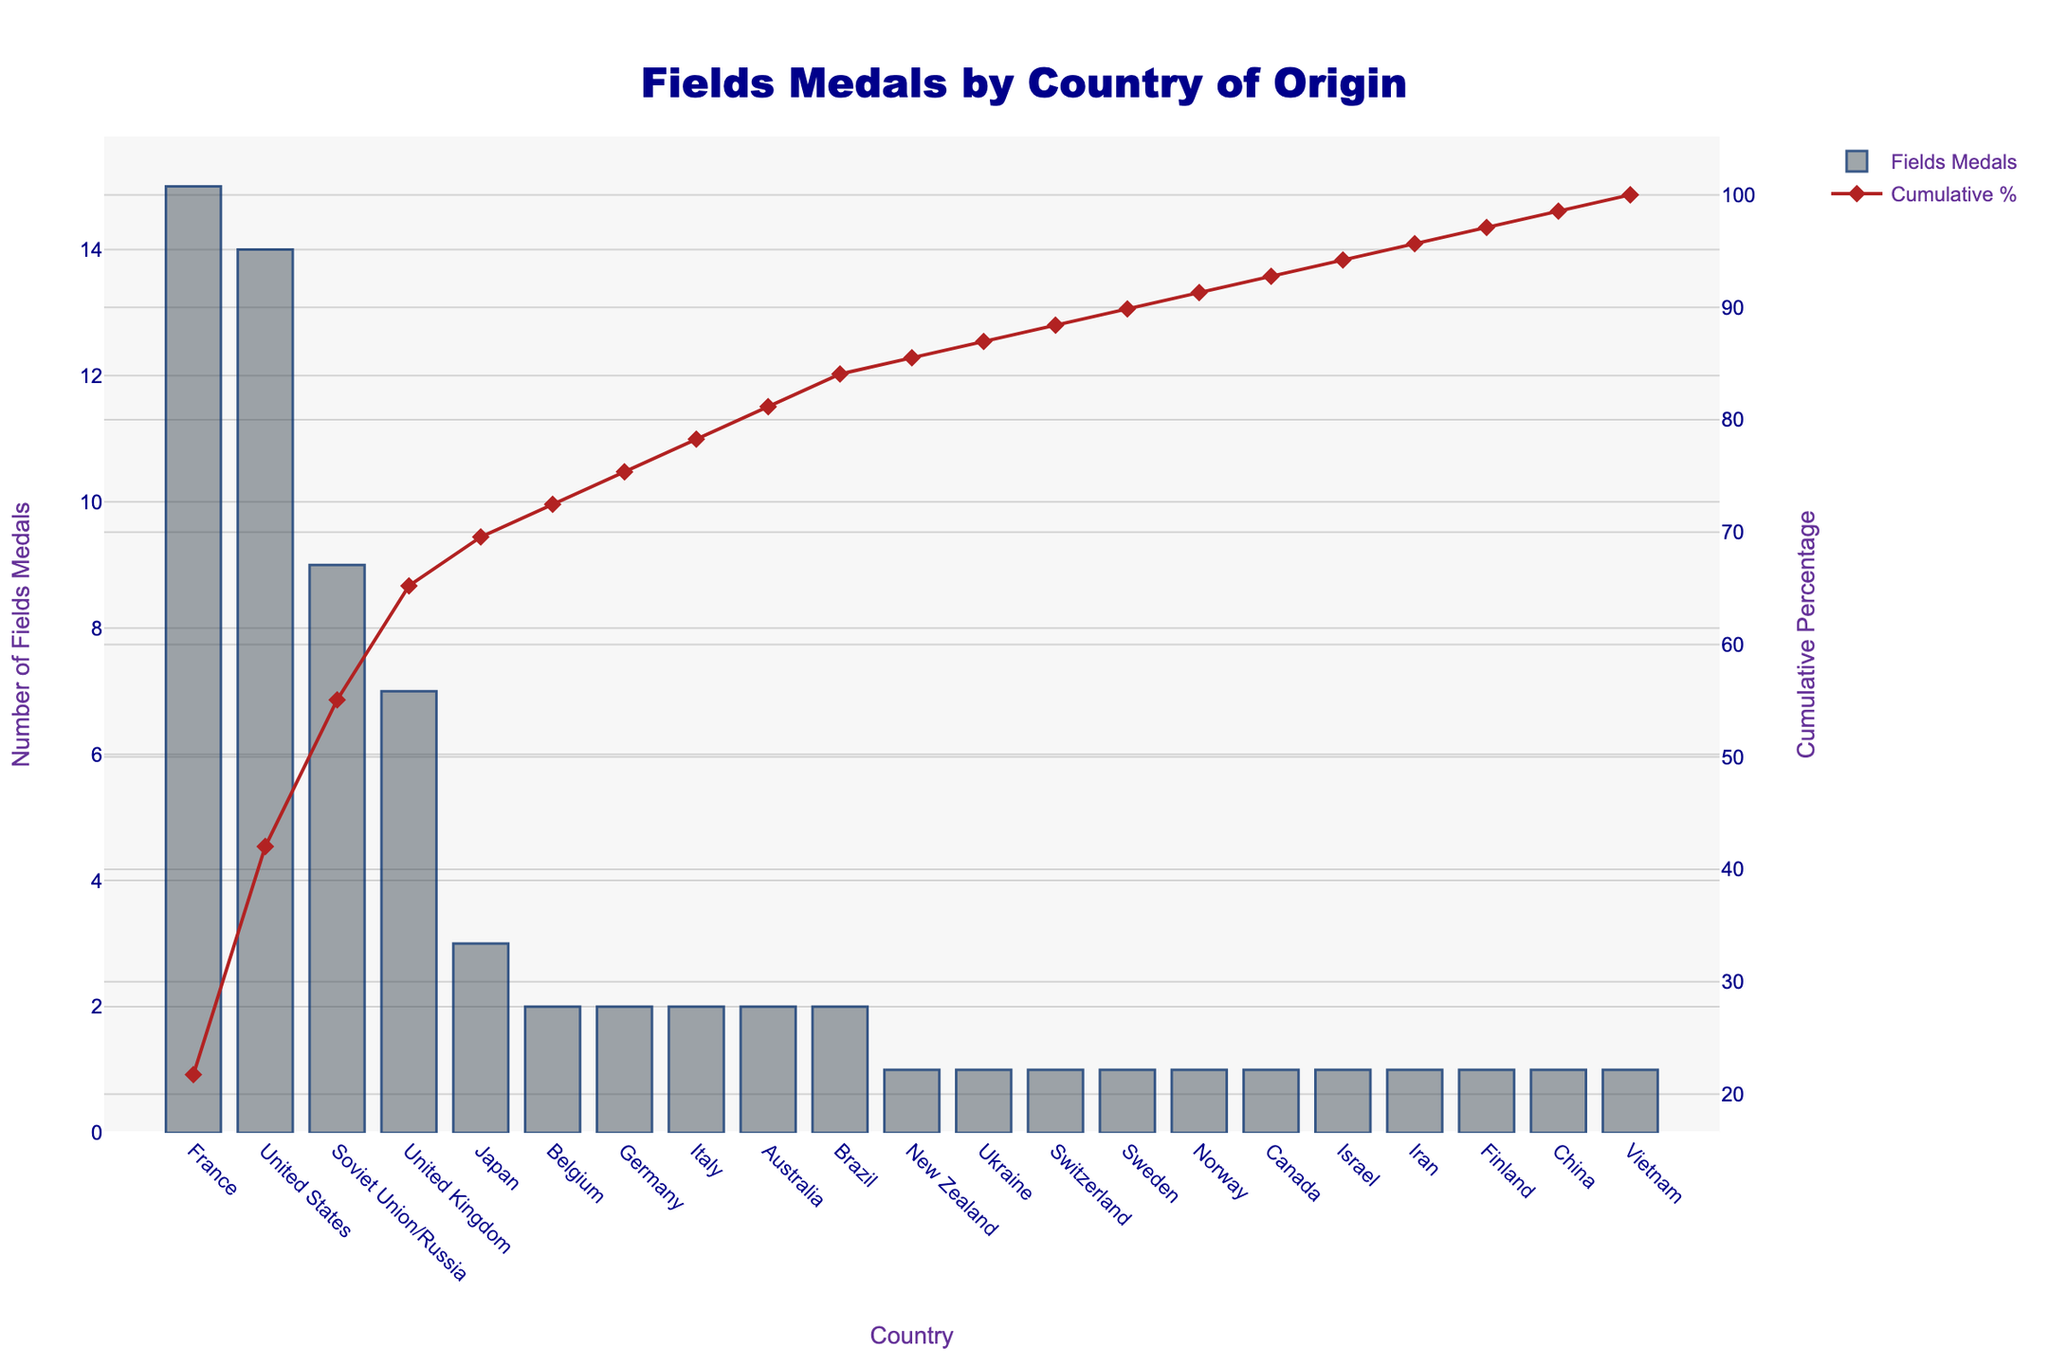Which country has the highest number of Fields Medals? By observing the height of the bars, the tallest bar corresponds to France, indicating it has the highest number of Fields Medals.
Answer: France What is the total number of Fields Medals awarded to France and the United States combined? France has 15 medals and the United States has 14 medals. Adding these together gives 15 + 14 = 29.
Answer: 29 Which country has the fewest Fields Medals? The shortest bars, each representing one medal, correspond to multiple countries: Canada, China, Finland, Iran, Israel, New Zealand, Norway, Sweden, Switzerland, Ukraine, and Vietnam.
Answer: Multiple countries (each with 1) What percentage of the total Fields Medals does the United States have? The total number of medals awarded is the sum of the medals from all countries. The US has 14 medals. First, identify the sum of all medals: 15 + 14 + 9 + 7 + ... + 1 = 66. Calculate the percentage: (14 / 66) * 100 ≈ 21.21%.
Answer: 21.21% How many countries have been awarded exactly 2 Fields Medals? Count the number of bars with a height of 2. These bars correspond to Belgium, Germany, Italy, Australia, and Brazil. Thus, there are 5 countries.
Answer: 5 countries What is the cumulative percentage of Fields Medals awarded up to the United Kingdom? The cumulative percentages are illustrated by the line graph. Up to the United Kingdom (France + US + Soviet Union/Russia + UK), match the corresponding y-value on the secondary y-axis. The cumulative percentage for the UK is around 67%.
Answer: 67% Which country awarded more Fields Medals, United Kingdom or Soviet Union/Russia? By comparing the heights of their respective bars, it is evident that the Soviet Union/Russia (9 medals) awarded more than the United Kingdom (7 medals).
Answer: Soviet Union/Russia What is the combined cumulative percentage of Fields Medals for France, the United States, and Soviet Union/Russia? From the cumulative percentage line, France (first bar) ≈ 22.73%, US (second bar) adds ≈ 21.21%, and Soviet Union/Russia (third bar) adds ≈ 13.64%. Summing these values gives approximately 22.73% + 21.21% + 13.64% = 57.58%.
Answer: 57.58% What is the difference in the number of Fields Medals between France and the United Kingdom? France has 15 medals and the United Kingdom has 7 medals. The difference is calculated as 15 - 7 = 8.
Answer: 8 What color represents the line graph for the cumulative percentage? The cumulative percentage is represented by a line graph in red with diamond-shaped markers.
Answer: Red Is there a country that has exactly half the number of Fields Medals as France? France has 15 medals. Half of 15 is 7.5. No bar corresponds exactly to 7.5 medals; thus, there is no country with exactly half the number of Fields Medals as France.
Answer: No 